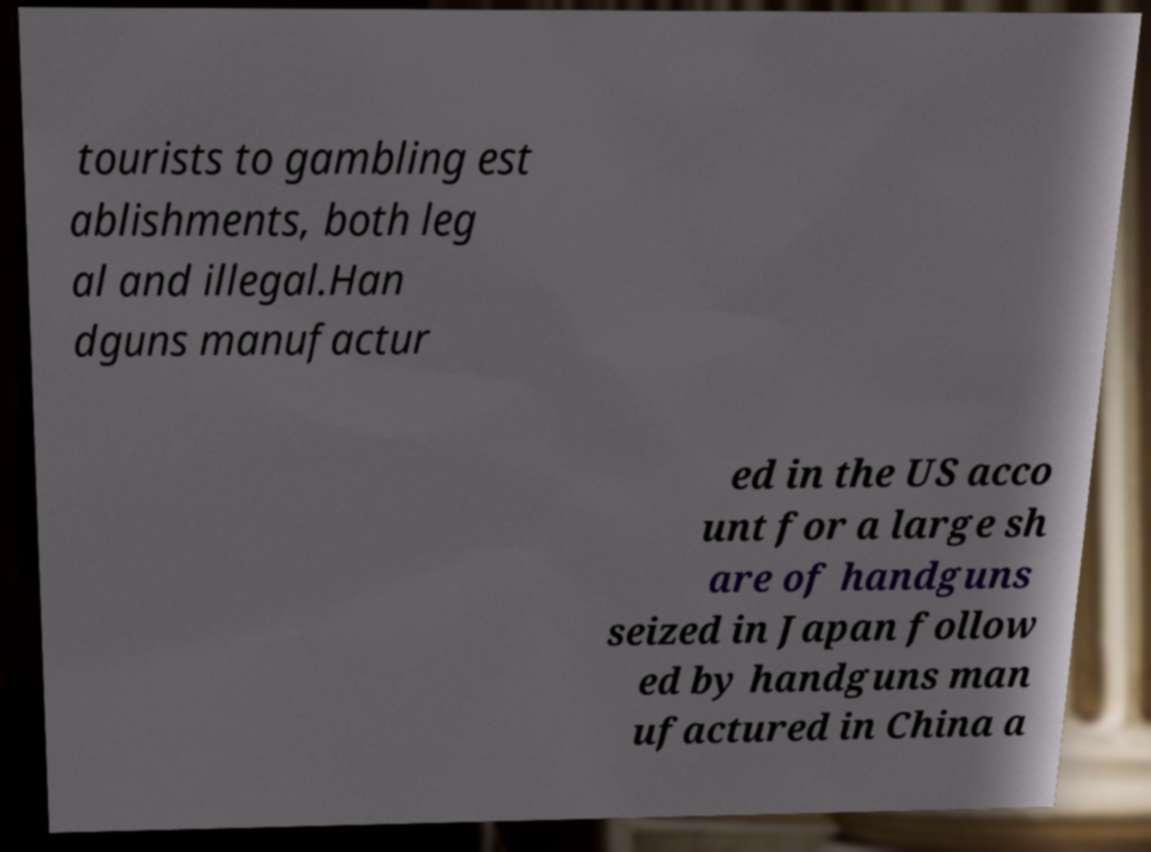Could you extract and type out the text from this image? tourists to gambling est ablishments, both leg al and illegal.Han dguns manufactur ed in the US acco unt for a large sh are of handguns seized in Japan follow ed by handguns man ufactured in China a 